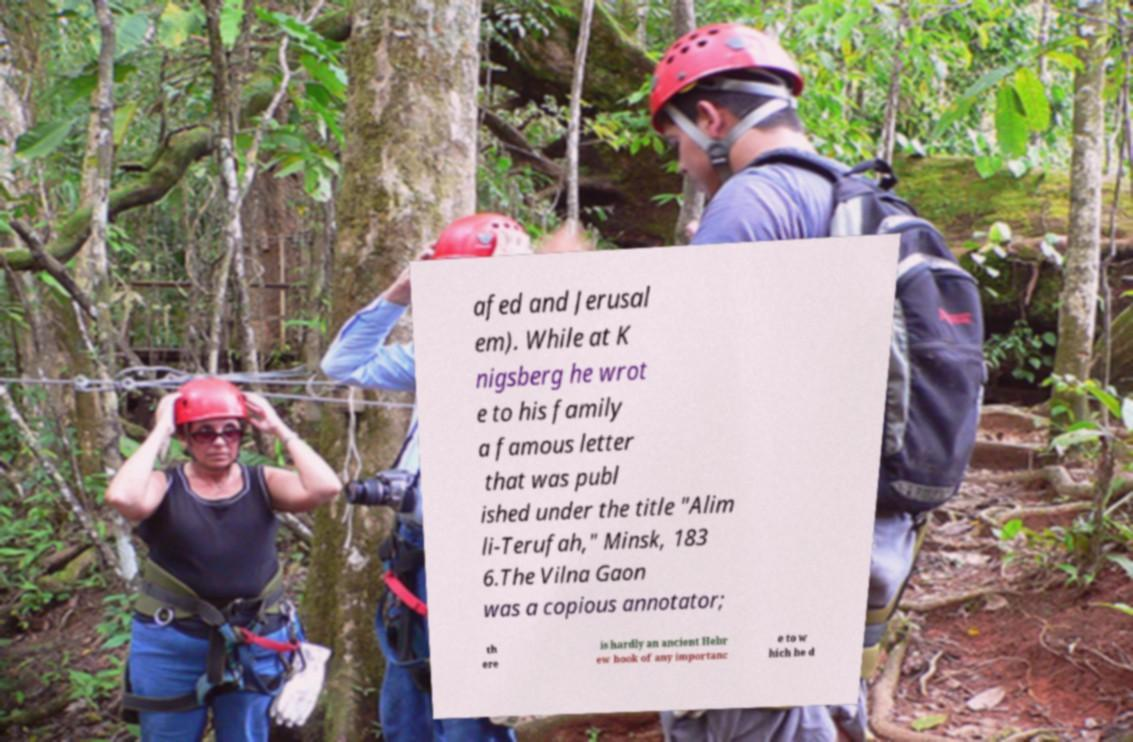Please read and relay the text visible in this image. What does it say? afed and Jerusal em). While at K nigsberg he wrot e to his family a famous letter that was publ ished under the title "Alim li-Terufah," Minsk, 183 6.The Vilna Gaon was a copious annotator; th ere is hardly an ancient Hebr ew book of any importanc e to w hich he d 